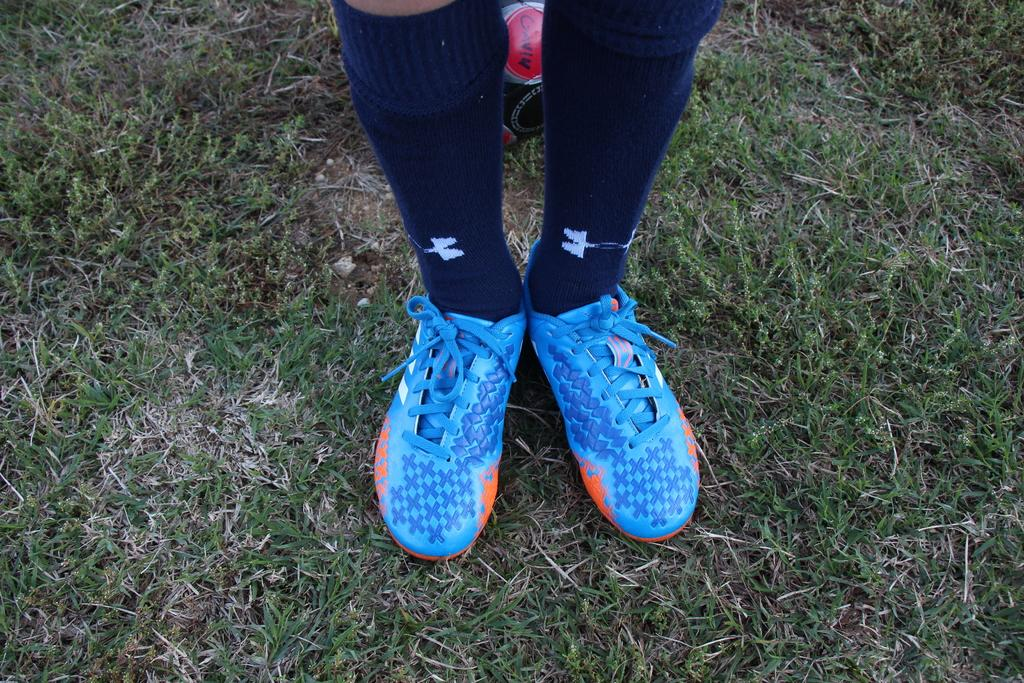What part of a person can be seen in the image? There are legs of a person visible in the image. What type of footwear is the person wearing? The person is wearing shoes. What type of terrain is visible in the image? There is grass on the ground in the image. What type of haircut does the camera have in the image? There is no camera present in the image, and therefore no haircut can be observed. 